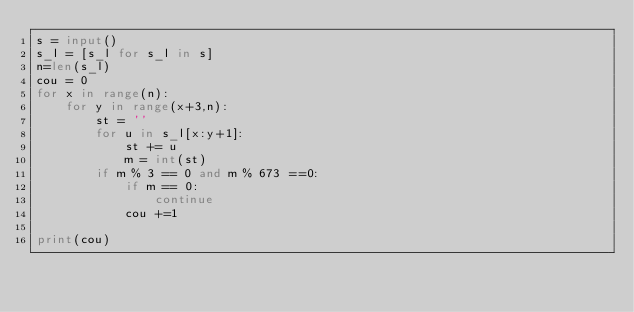<code> <loc_0><loc_0><loc_500><loc_500><_Python_>s = input()
s_l = [s_l for s_l in s]
n=len(s_l)
cou = 0
for x in range(n):
    for y in range(x+3,n):
        st = ''
        for u in s_l[x:y+1]:
            st += u
            m = int(st)
        if m % 3 == 0 and m % 673 ==0:
            if m == 0:
                continue
            cou +=1
            
print(cou)</code> 